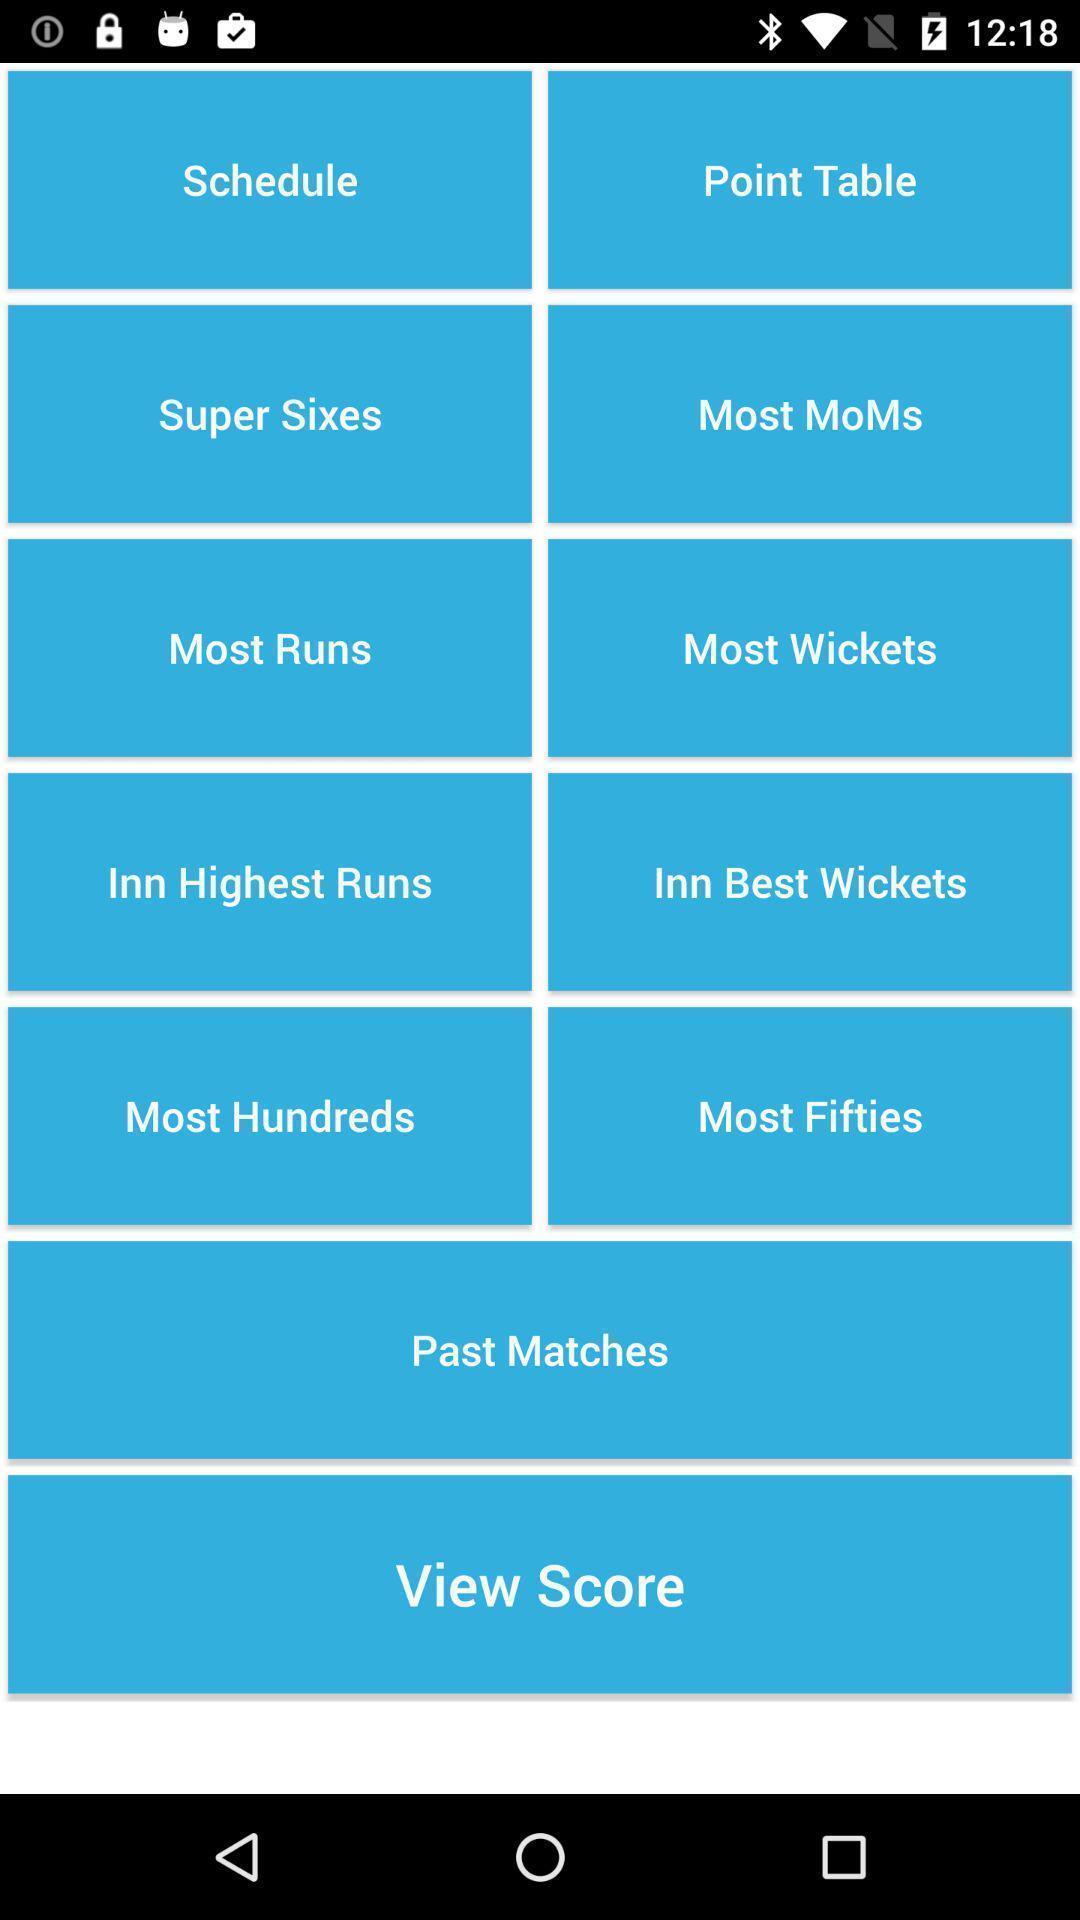Summarize the main components in this picture. Window displaying with all cricket updates. 